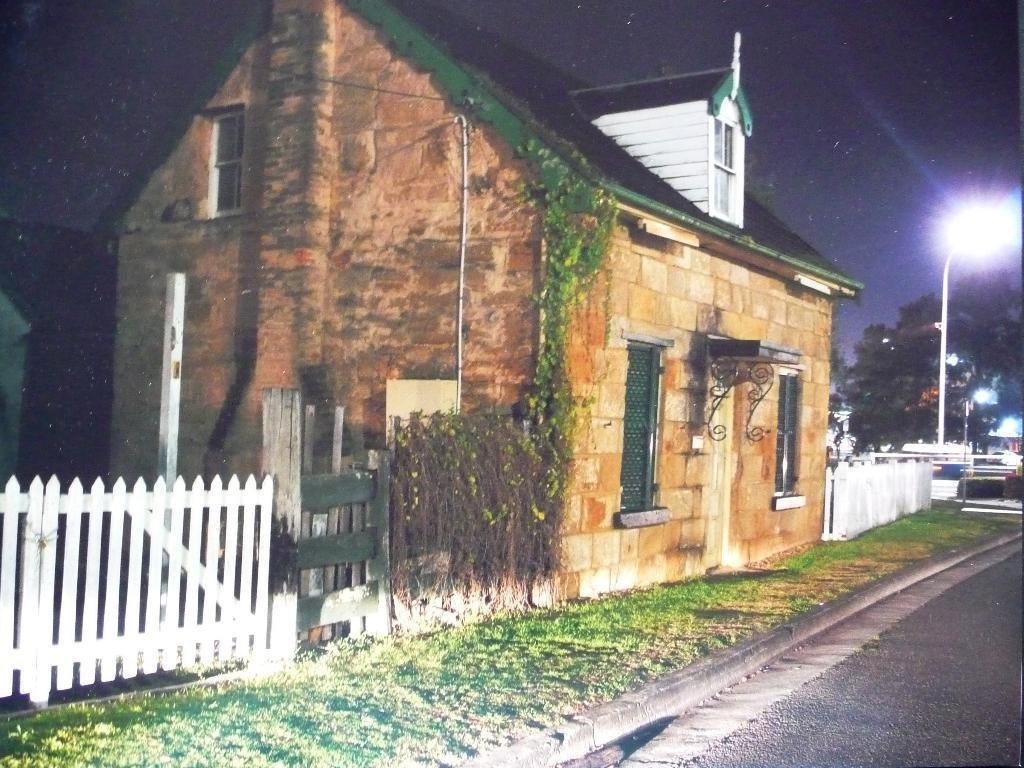What is the color of the house in the image? The house in the image is brown. What type of roofing does the house have? The house has roofing tiles. What is located beside the house? There is a white color wooden gate beside the house. What can be seen in the right corner of the image? There are trees and street lights in the right corner of the image. What type of punishment is being given to the house in the image? There is no punishment being given to the house in the image; it is simply a house with a brown color and roofing tiles. 